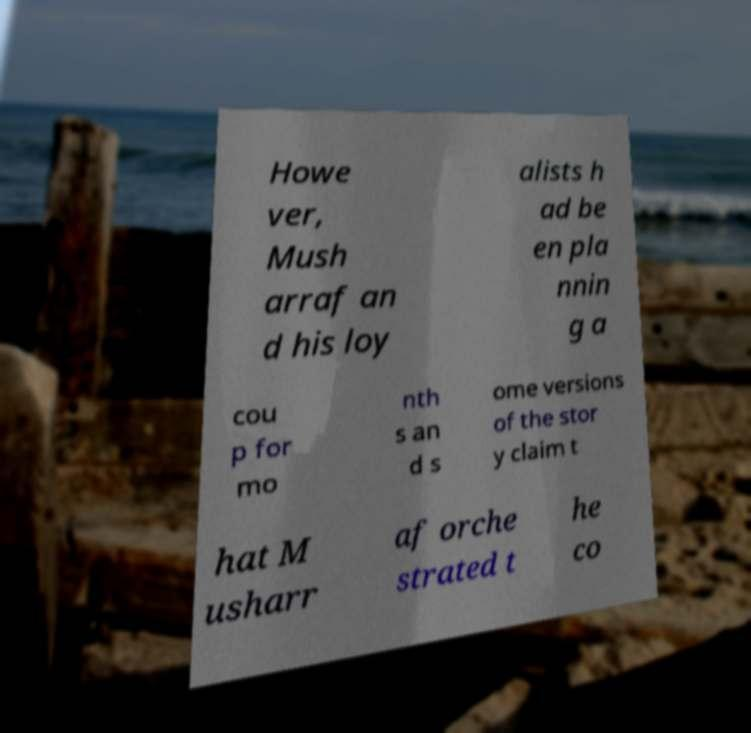There's text embedded in this image that I need extracted. Can you transcribe it verbatim? Howe ver, Mush arraf an d his loy alists h ad be en pla nnin g a cou p for mo nth s an d s ome versions of the stor y claim t hat M usharr af orche strated t he co 